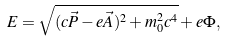<formula> <loc_0><loc_0><loc_500><loc_500>E = \sqrt { ( c \vec { P } - e \vec { A } ) ^ { 2 } + m _ { 0 } ^ { 2 } c ^ { 4 } } + e \Phi ,</formula> 